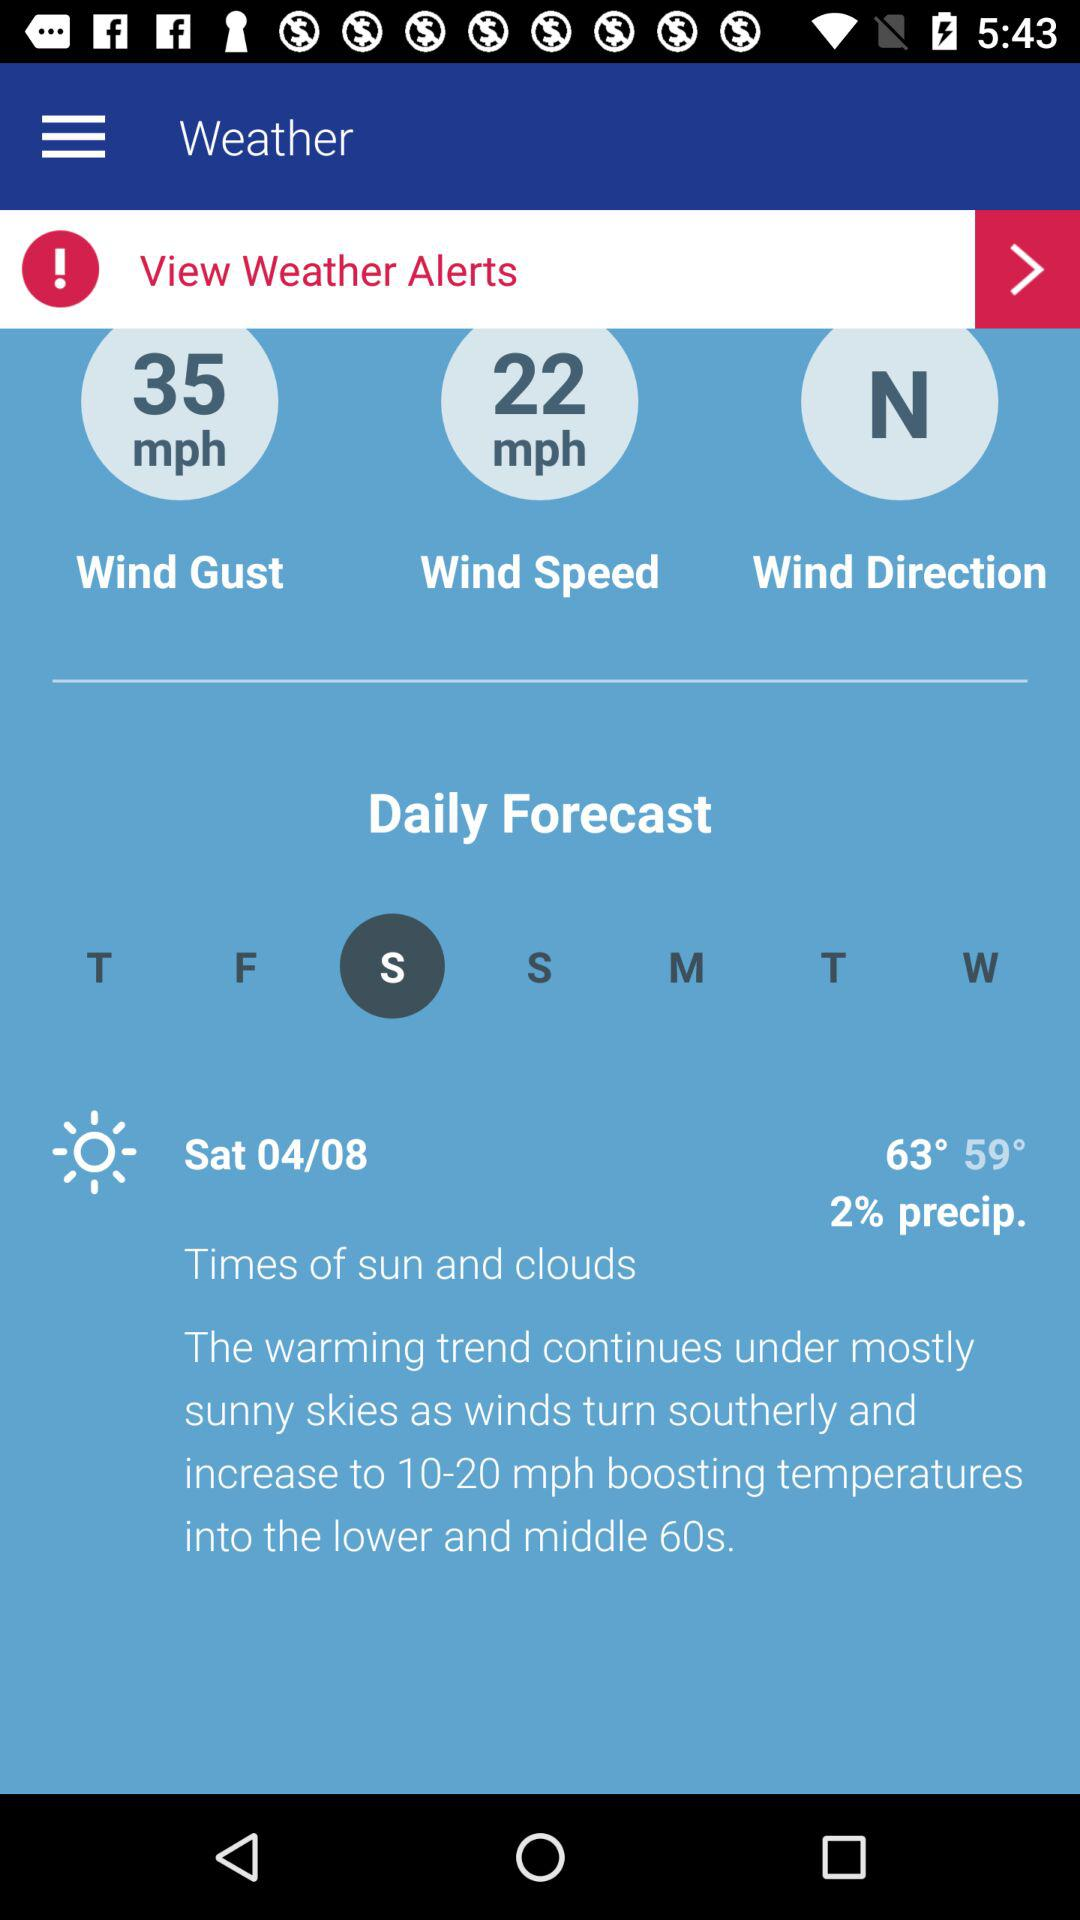What is the selected day? The day is Saturday. 